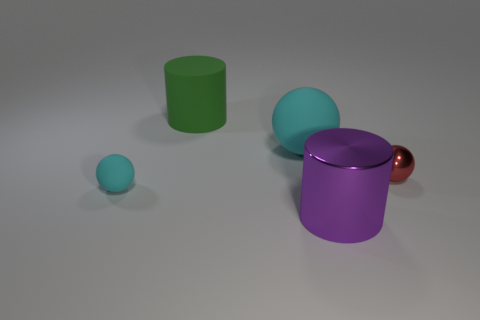What is the color of the large shiny object?
Give a very brief answer. Purple. The big object right of the large cyan thing has what shape?
Give a very brief answer. Cylinder. Is there a large cyan sphere to the left of the big cylinder behind the cyan ball that is on the left side of the large cyan thing?
Make the answer very short. No. Are any tiny red matte cylinders visible?
Give a very brief answer. No. Are the cylinder behind the big purple shiny cylinder and the large cylinder on the right side of the large green matte cylinder made of the same material?
Ensure brevity in your answer.  No. There is a metal object behind the matte ball left of the cylinder that is behind the large purple metallic cylinder; how big is it?
Provide a succinct answer. Small. How many small cyan spheres are the same material as the purple cylinder?
Provide a short and direct response. 0. Is the number of tiny objects less than the number of red shiny things?
Your answer should be compact. No. What is the size of the red shiny object that is the same shape as the tiny cyan rubber object?
Your response must be concise. Small. Is the material of the big sphere behind the tiny matte ball the same as the big purple thing?
Your answer should be very brief. No. 